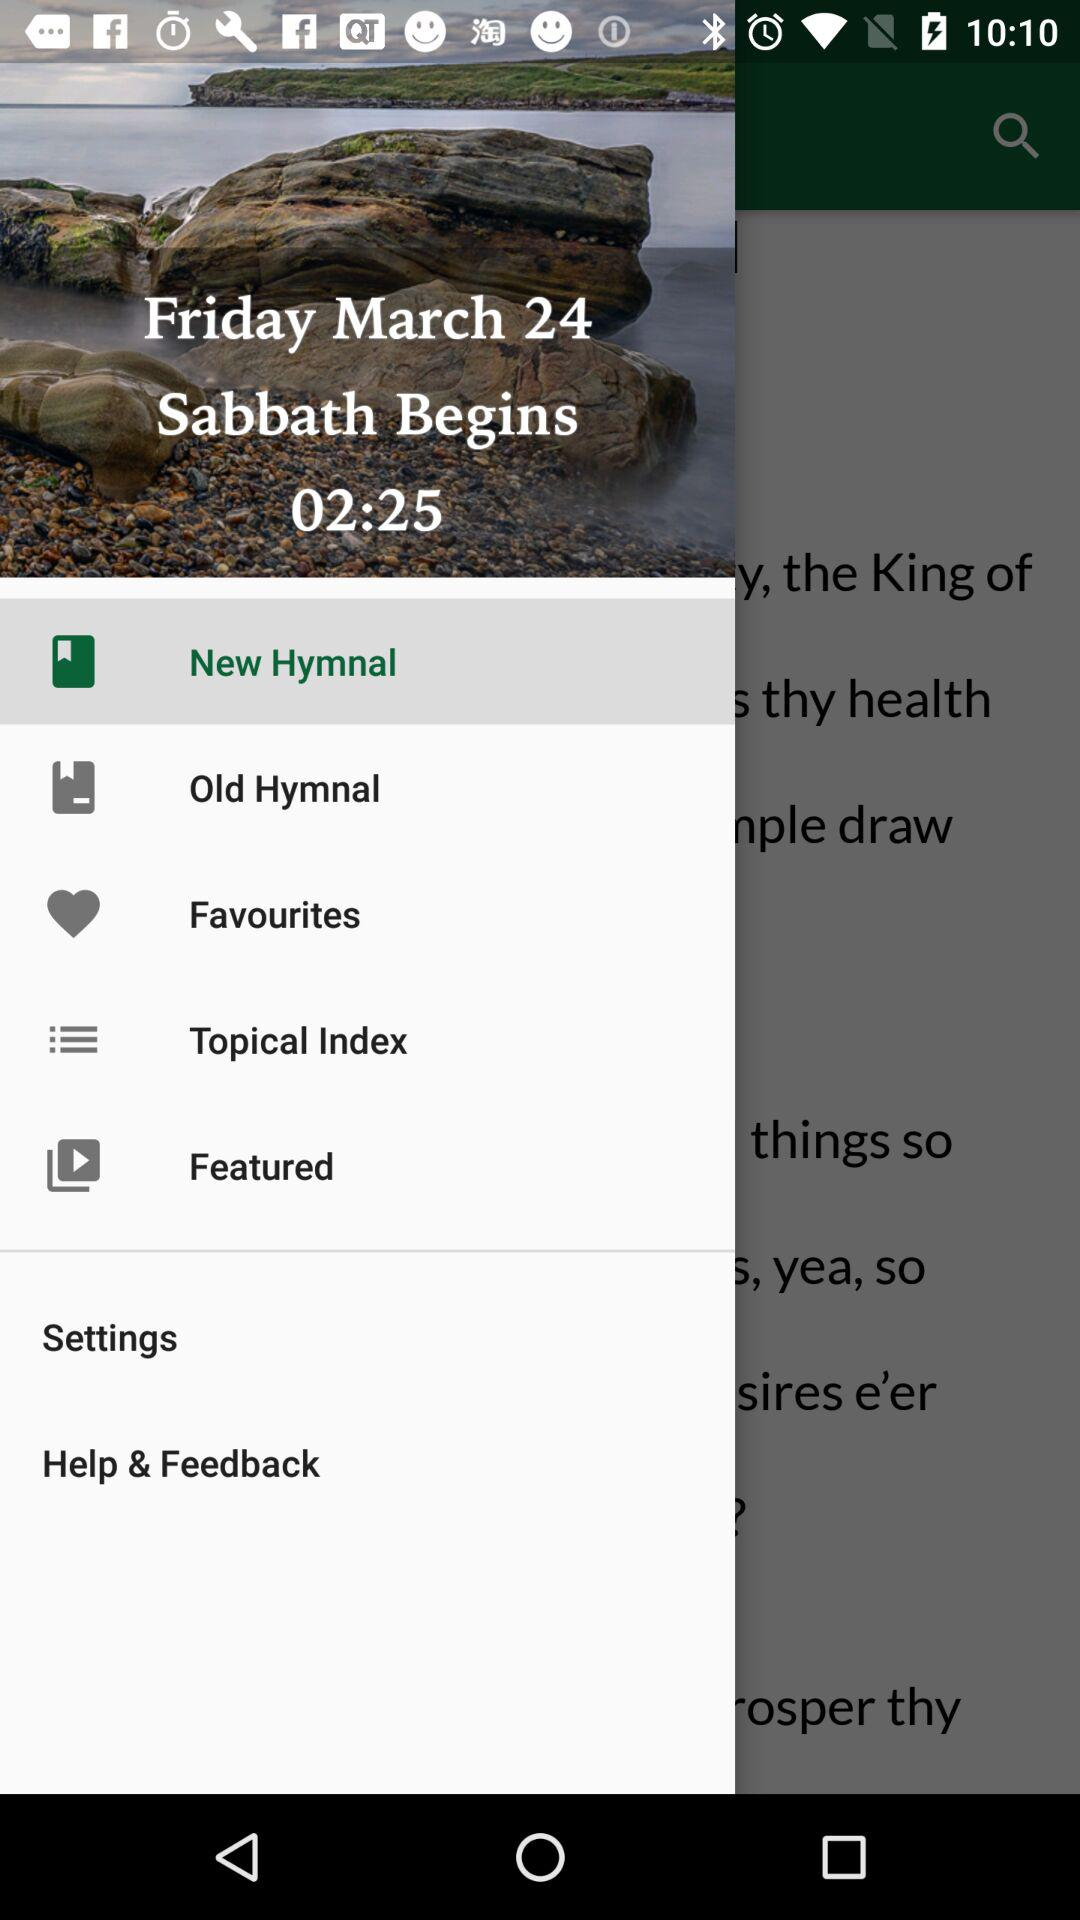What option is selected? The selected option is "New Hymnal". 